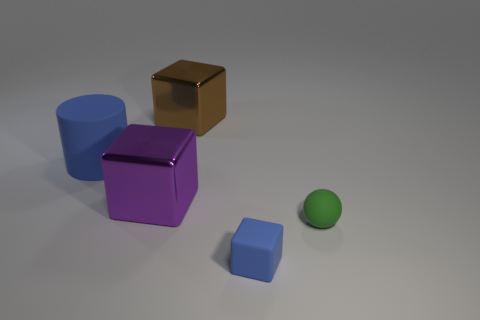Subtract all blue rubber cubes. How many cubes are left? 2 Subtract 1 cubes. How many cubes are left? 2 Subtract all brown blocks. How many blocks are left? 2 Subtract all cylinders. How many objects are left? 4 Add 4 big cubes. How many objects exist? 9 Subtract 0 yellow cubes. How many objects are left? 5 Subtract all blue blocks. Subtract all red balls. How many blocks are left? 2 Subtract all gray cylinders. How many purple balls are left? 0 Subtract all tiny matte things. Subtract all big matte cylinders. How many objects are left? 2 Add 1 small things. How many small things are left? 3 